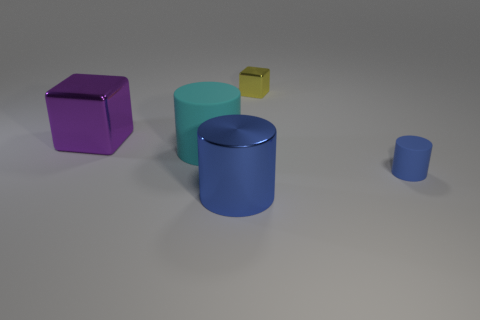How many blue cylinders must be subtracted to get 1 blue cylinders? 1 Add 4 small gray blocks. How many objects exist? 9 Subtract all big matte cylinders. How many cylinders are left? 2 Subtract all cubes. How many objects are left? 3 Subtract all cyan cylinders. How many cylinders are left? 2 Subtract 1 cylinders. How many cylinders are left? 2 Subtract all large yellow cylinders. Subtract all big metal objects. How many objects are left? 3 Add 5 small rubber cylinders. How many small rubber cylinders are left? 6 Add 5 big purple metallic cylinders. How many big purple metallic cylinders exist? 5 Subtract 1 purple cubes. How many objects are left? 4 